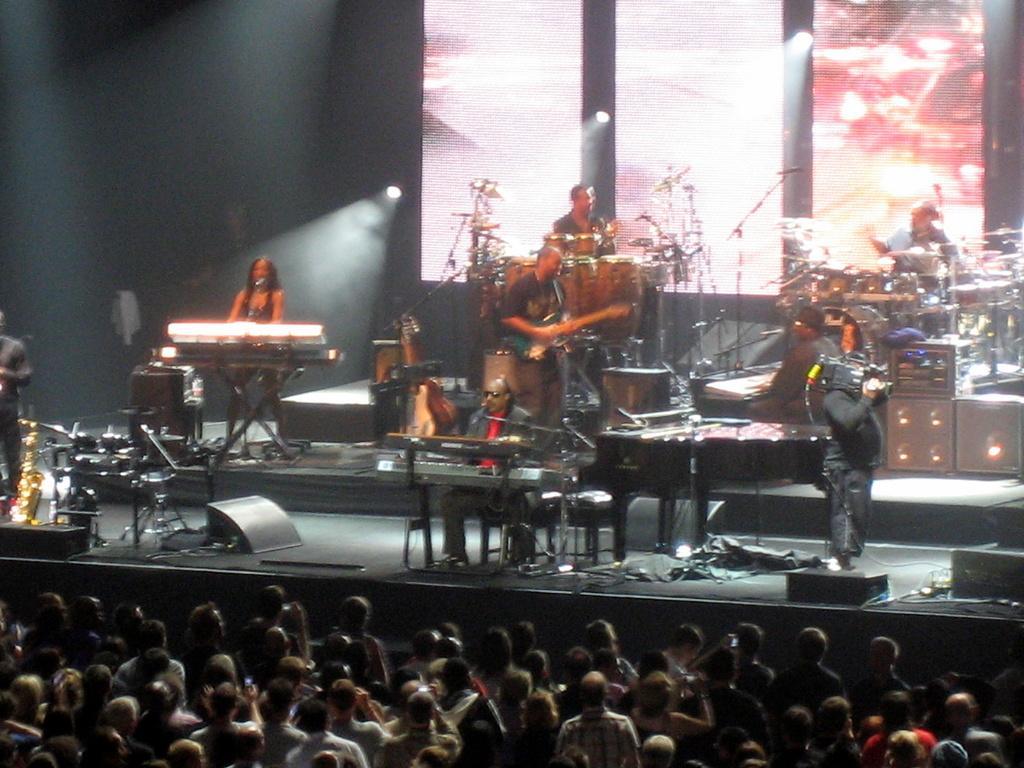In one or two sentences, can you explain what this image depicts? In the image we can see there are people standing on the stage and they are playing musical instruments. Behind there is projector screen and there are spectators watching them. 